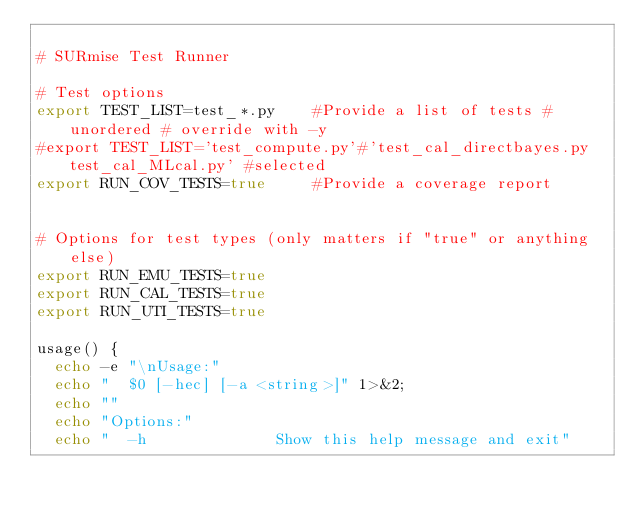<code> <loc_0><loc_0><loc_500><loc_500><_Bash_>
# SURmise Test Runner

# Test options
export TEST_LIST=test_*.py    #Provide a list of tests #unordered # override with -y
#export TEST_LIST='test_compute.py'#'test_cal_directbayes.py test_cal_MLcal.py' #selected
export RUN_COV_TESTS=true     #Provide a coverage report


# Options for test types (only matters if "true" or anything else)
export RUN_EMU_TESTS=true
export RUN_CAL_TESTS=true
export RUN_UTI_TESTS=true

usage() {
  echo -e "\nUsage:"
  echo "  $0 [-hec] [-a <string>]" 1>&2;
  echo ""
  echo "Options:"
  echo "  -h              Show this help message and exit"</code> 